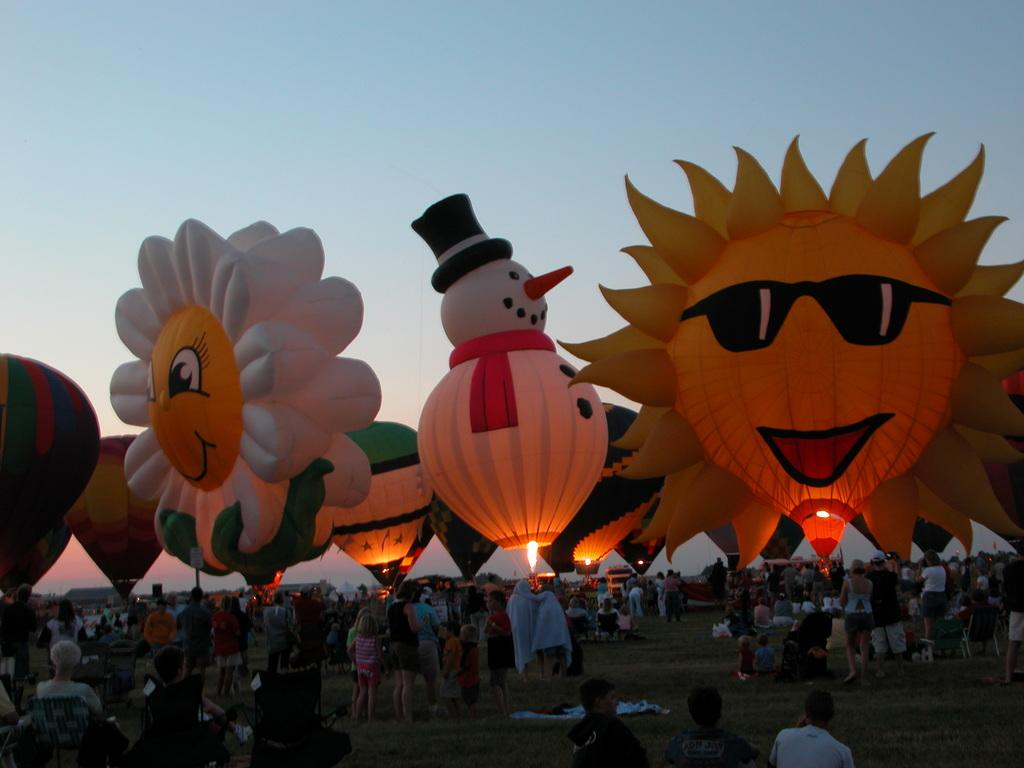What objects are present in the sky in the image? There are parachutes in the image. What are the people in the image doing? The people are standing on the ground in the image. What is visible at the top of the image? The sky is visible at the top of the image. What is the source of the fire near the parachutes in the image? The facts provided do not specify the source of the fire near the parachutes. What type of prose is being read by the people on the ground in the image? There is no indication in the image that the people are reading any prose. Can you tell me if the volcano in the image has received approval from the local authorities? There is no volcano present in the image, so it is not possible to determine if it has received approval from the local authorities. 